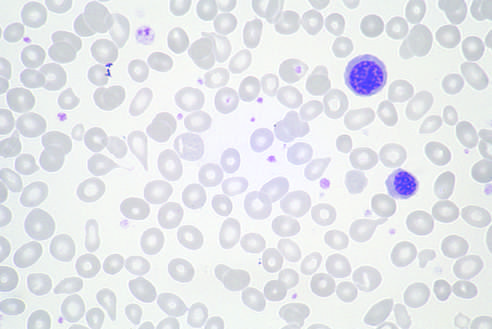was a myofiber distended with trypanosomes present in other fields?
Answer the question using a single word or phrase. No 